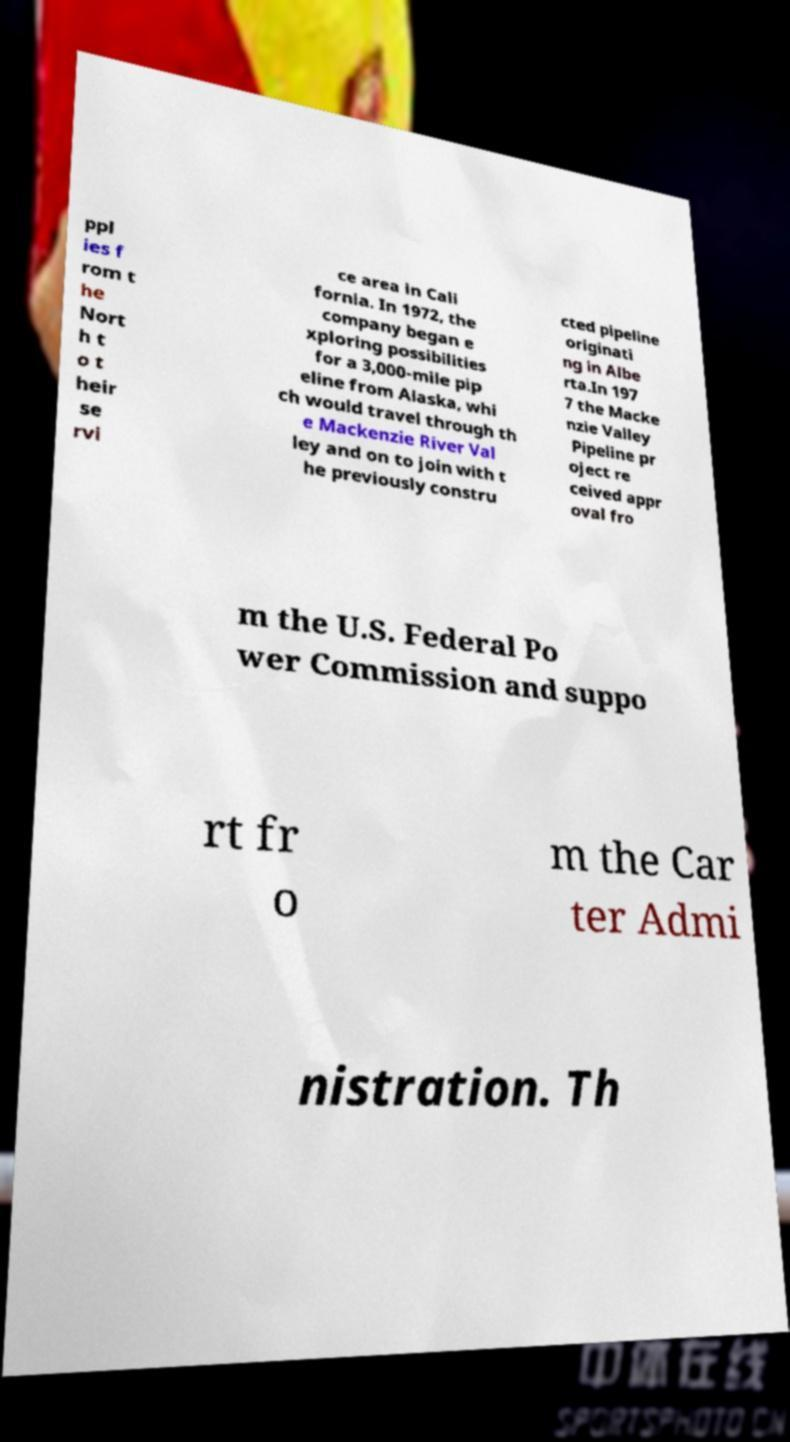Can you accurately transcribe the text from the provided image for me? ppl ies f rom t he Nort h t o t heir se rvi ce area in Cali fornia. In 1972, the company began e xploring possibilities for a 3,000-mile pip eline from Alaska, whi ch would travel through th e Mackenzie River Val ley and on to join with t he previously constru cted pipeline originati ng in Albe rta.In 197 7 the Macke nzie Valley Pipeline pr oject re ceived appr oval fro m the U.S. Federal Po wer Commission and suppo rt fr o m the Car ter Admi nistration. Th 